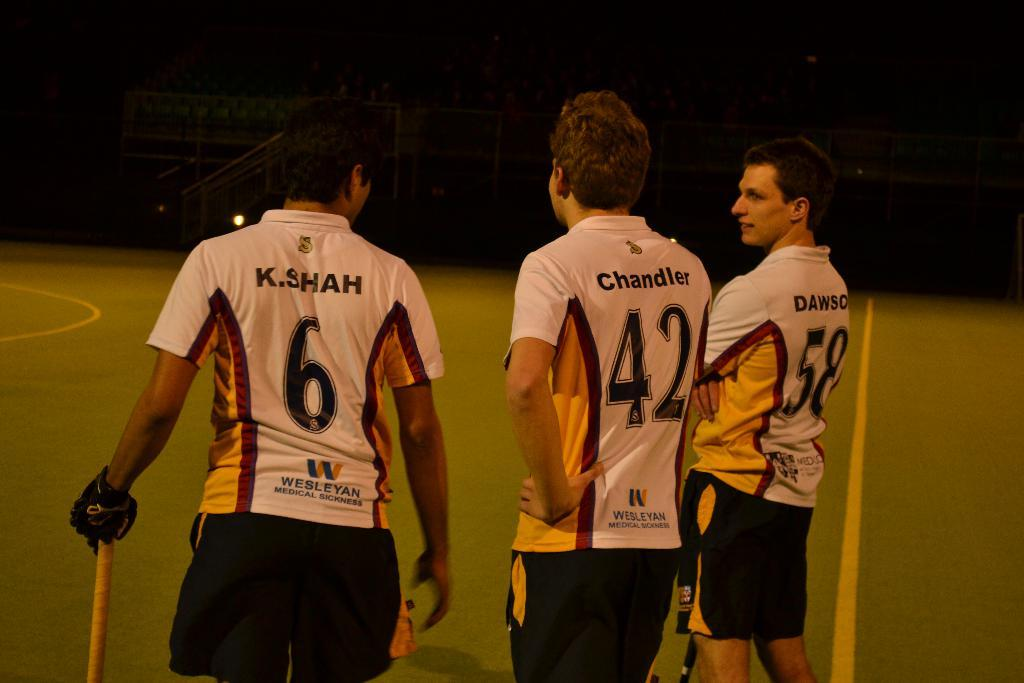<image>
Summarize the visual content of the image. Three sports players sponsored by Wesleyan Medical Sickness. 